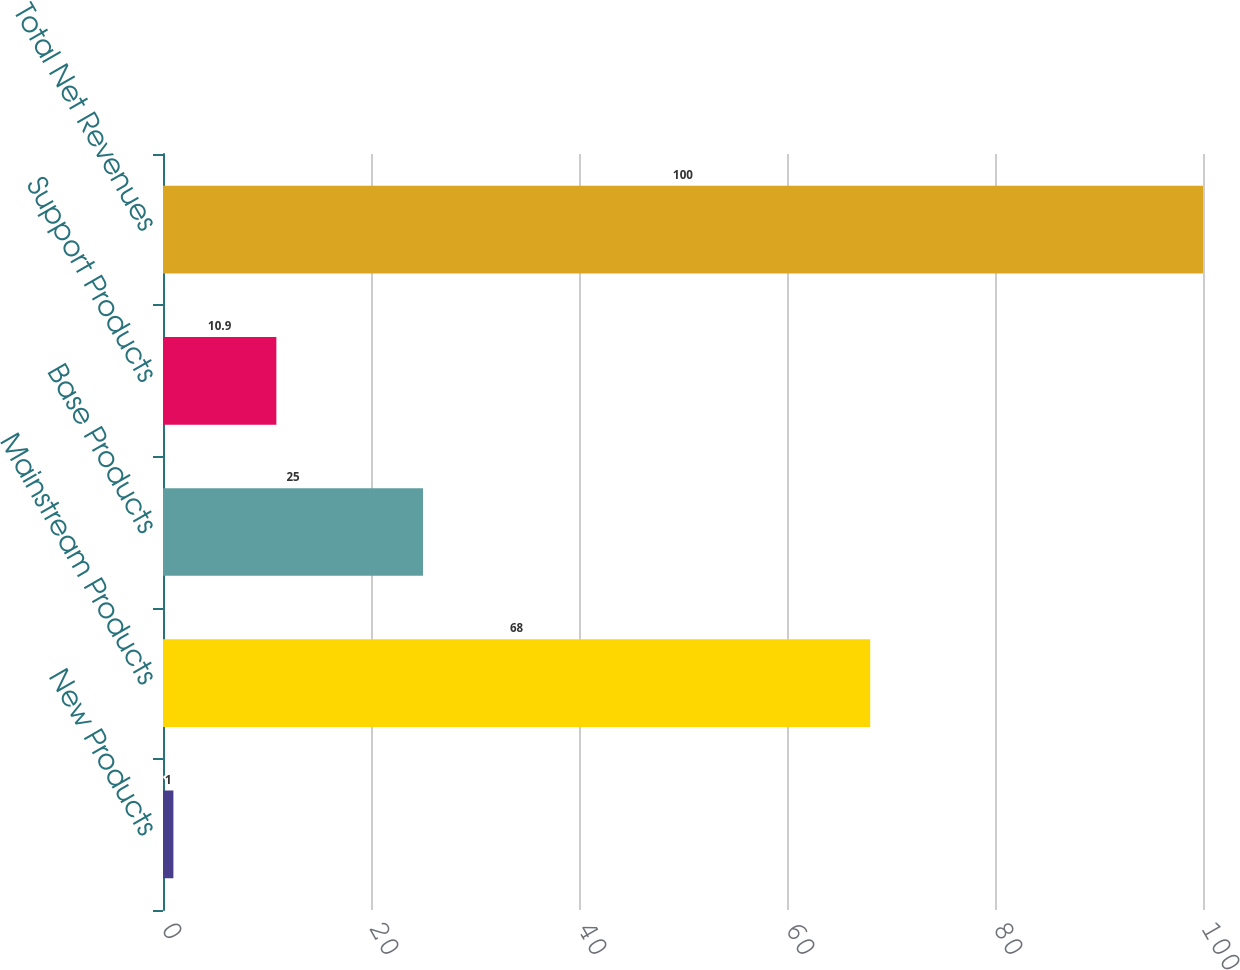<chart> <loc_0><loc_0><loc_500><loc_500><bar_chart><fcel>New Products<fcel>Mainstream Products<fcel>Base Products<fcel>Support Products<fcel>Total Net Revenues<nl><fcel>1<fcel>68<fcel>25<fcel>10.9<fcel>100<nl></chart> 